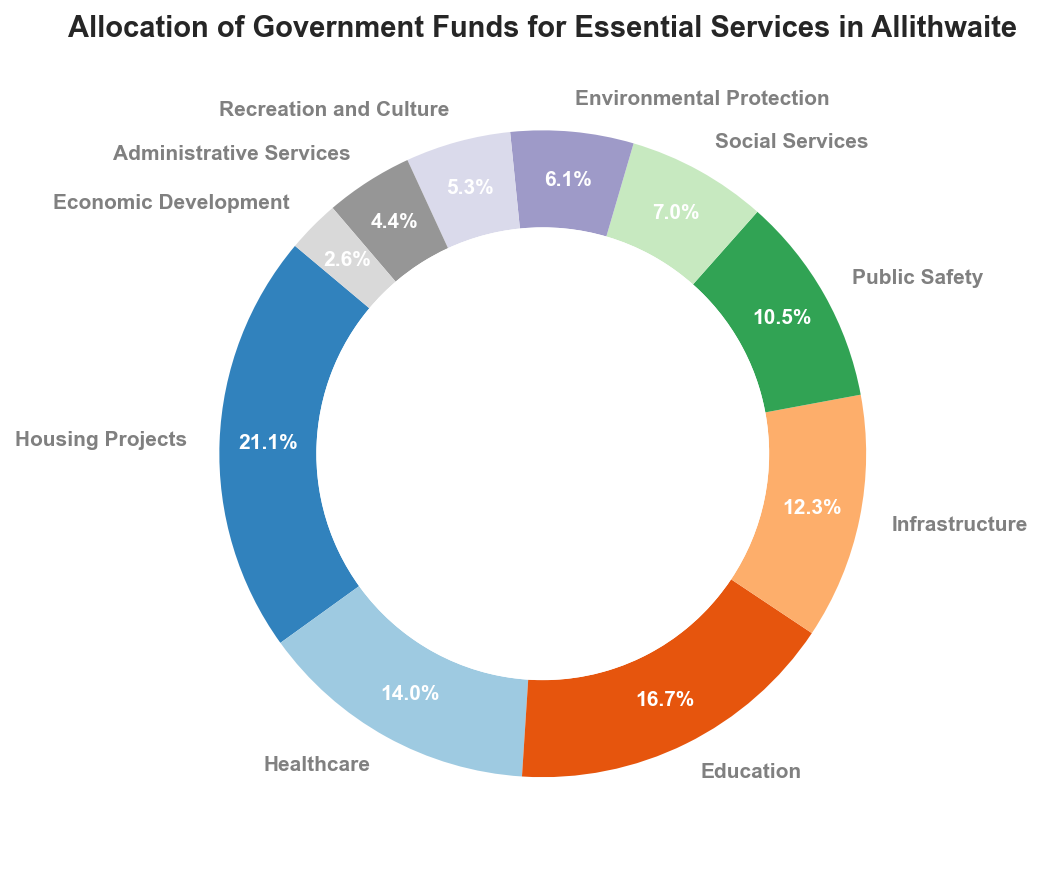Which category receives the highest allocation of government funds? The ring chart shows slices with different fund allocations. The slice labeled "Housing Projects" is the largest, indicating that it receives the highest allocation.
Answer: Housing Projects How much more is allocated to Housing Projects compared to Public Safety? From the chart, Housing Projects receive 1,200,000, and Public Safety receives 600,000. The difference is 1,200,000 - 600,000.
Answer: 600,000 What percentage of the total funds is allocated to Social Services? The ring chart provides percentage values for each category. The slice labeled "Social Services" shows 4.5%.
Answer: 4.5% Combine the funds allocated to Healthcare and Education, then compare it to Housing Projects. Is the total higher or lower? Healthcare receives 800,000 and Education receives 950,000. Their combined total is 800,000 + 950,000 = 1,750,000. Housing Projects receive 1,200,000.
Answer: Higher Which category has the smallest allocation of funds, and how much is allocated to it? The smallest slice in the ring chart is labeled "Economic Development," indicating it has the smallest allocation.
Answer: Economic Development, 150,000 How many categories receive less than 500,000? By observing the smaller slices in the ring chart, the categories "Social Services," "Environmental Protection," "Recreation and Culture," "Administrative Services," and "Economic Development" each receive less than 500,000.
Answer: 5 Compare Infrastructure and Public Safety allocations. Which one receives more funds? The ring chart indicates that "Infrastructure" has a larger slice than "Public Safety."
Answer: Infrastructure What is the average allocation amount for all the categories combined? The total funds allocated are the sum of all slice values: 1,200,000 + 800,000 + 950,000 + 700,000 + 600,000 + 400,000 + 350,000 + 300,000 + 250,000 + 150,000 = 5,700,000. There are 10 categories, so the average is 5,700,000 / 10.
Answer: 570,000 Combine the allocations for Environmental Protection and Recreation and Culture. What is the total percentage of the combined allocation? Environmental Protection is 6.1% and Recreation and Culture is 5.3%. Their combined percentage is 6.1% + 5.3%.
Answer: 11.4% Arrange the categories in descending order based on their allocation amounts. By visual inspection of the ring chart slices from largest to smallest: Housing Projects, Education, Healthcare, Infrastructure, Public Safety, Social Services, Environmental Protection, Recreation and Culture, Administrative Services, Economic Development.
Answer: Housing Projects, Education, Healthcare, Infrastructure, Public Safety, Social Services, Environmental Protection, Recreation and Culture, Administrative Services, Economic Development 